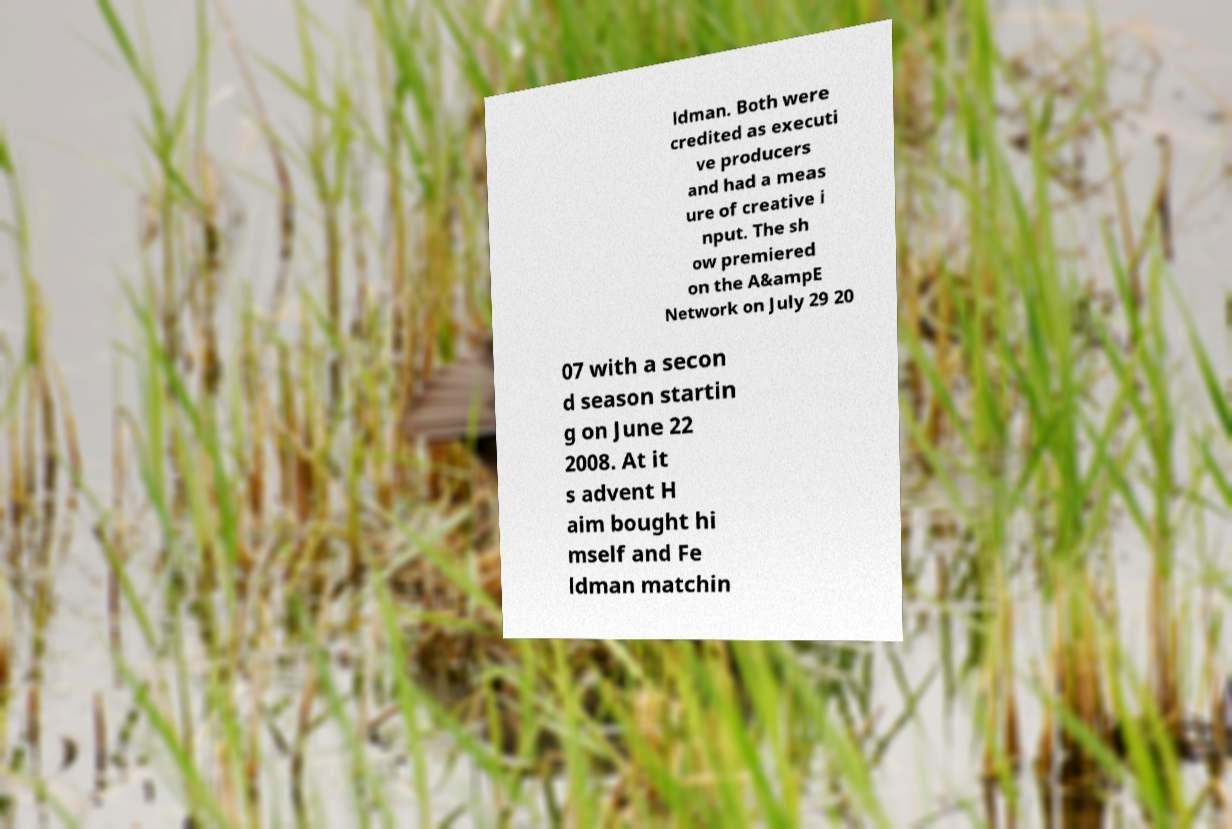For documentation purposes, I need the text within this image transcribed. Could you provide that? ldman. Both were credited as executi ve producers and had a meas ure of creative i nput. The sh ow premiered on the A&ampE Network on July 29 20 07 with a secon d season startin g on June 22 2008. At it s advent H aim bought hi mself and Fe ldman matchin 